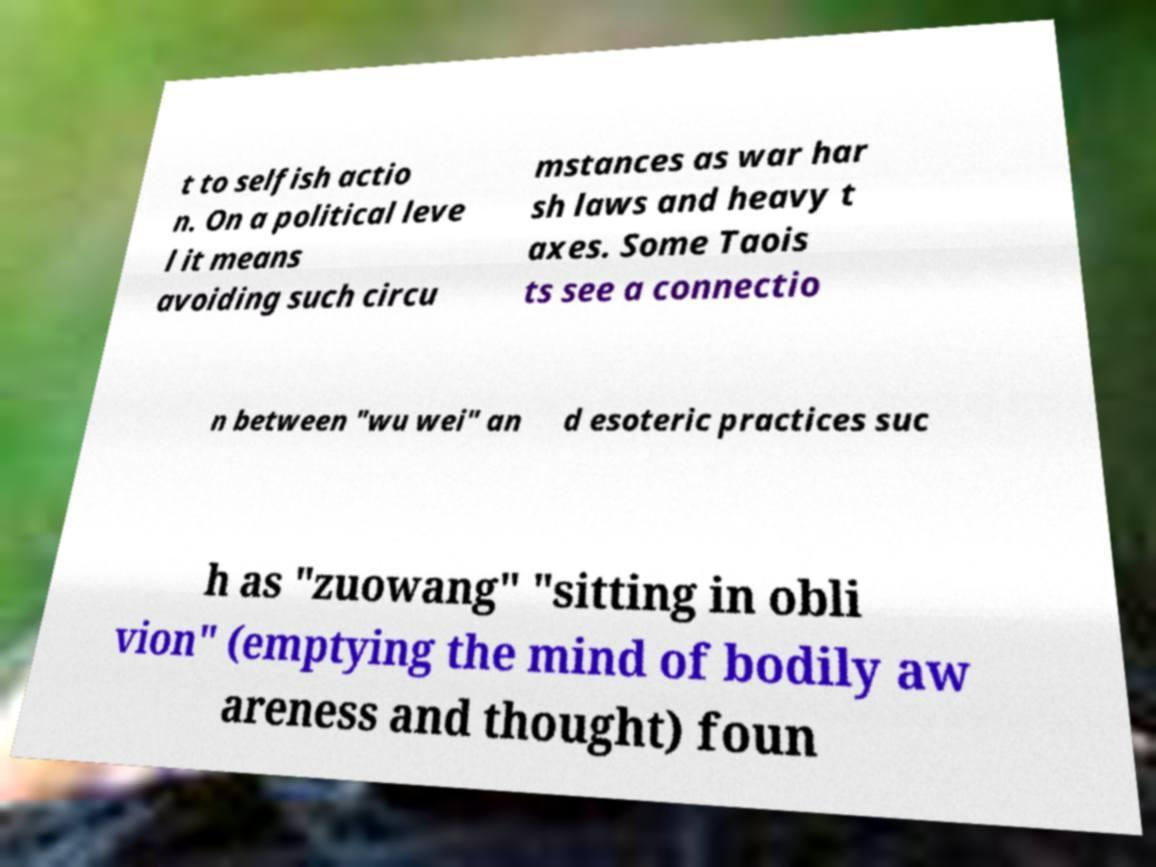There's text embedded in this image that I need extracted. Can you transcribe it verbatim? t to selfish actio n. On a political leve l it means avoiding such circu mstances as war har sh laws and heavy t axes. Some Taois ts see a connectio n between "wu wei" an d esoteric practices suc h as "zuowang" "sitting in obli vion" (emptying the mind of bodily aw areness and thought) foun 